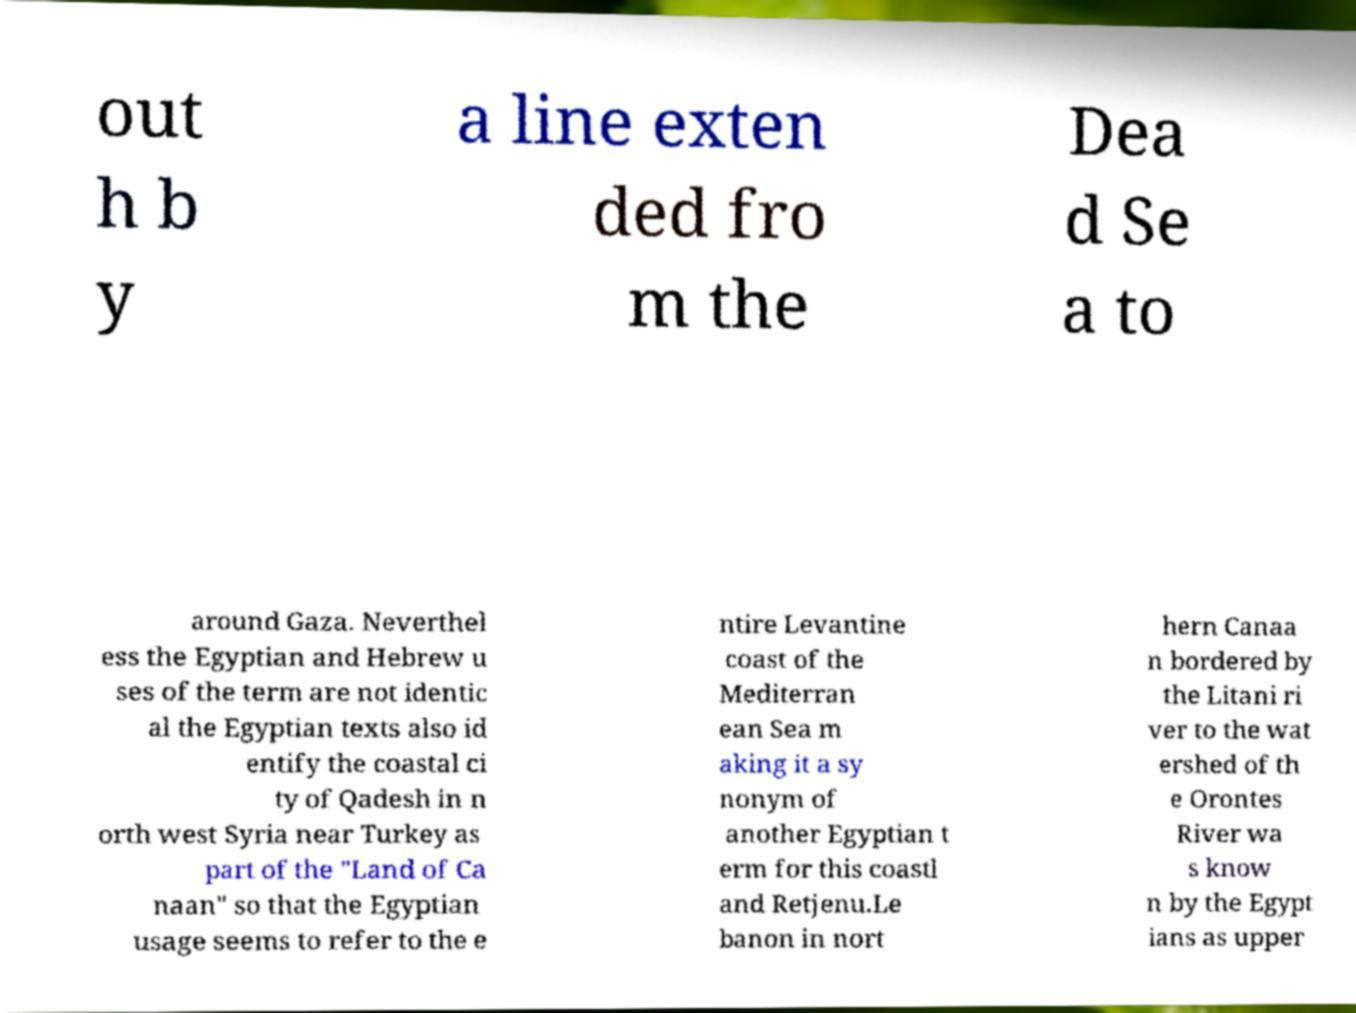Please identify and transcribe the text found in this image. out h b y a line exten ded fro m the Dea d Se a to around Gaza. Neverthel ess the Egyptian and Hebrew u ses of the term are not identic al the Egyptian texts also id entify the coastal ci ty of Qadesh in n orth west Syria near Turkey as part of the "Land of Ca naan" so that the Egyptian usage seems to refer to the e ntire Levantine coast of the Mediterran ean Sea m aking it a sy nonym of another Egyptian t erm for this coastl and Retjenu.Le banon in nort hern Canaa n bordered by the Litani ri ver to the wat ershed of th e Orontes River wa s know n by the Egypt ians as upper 